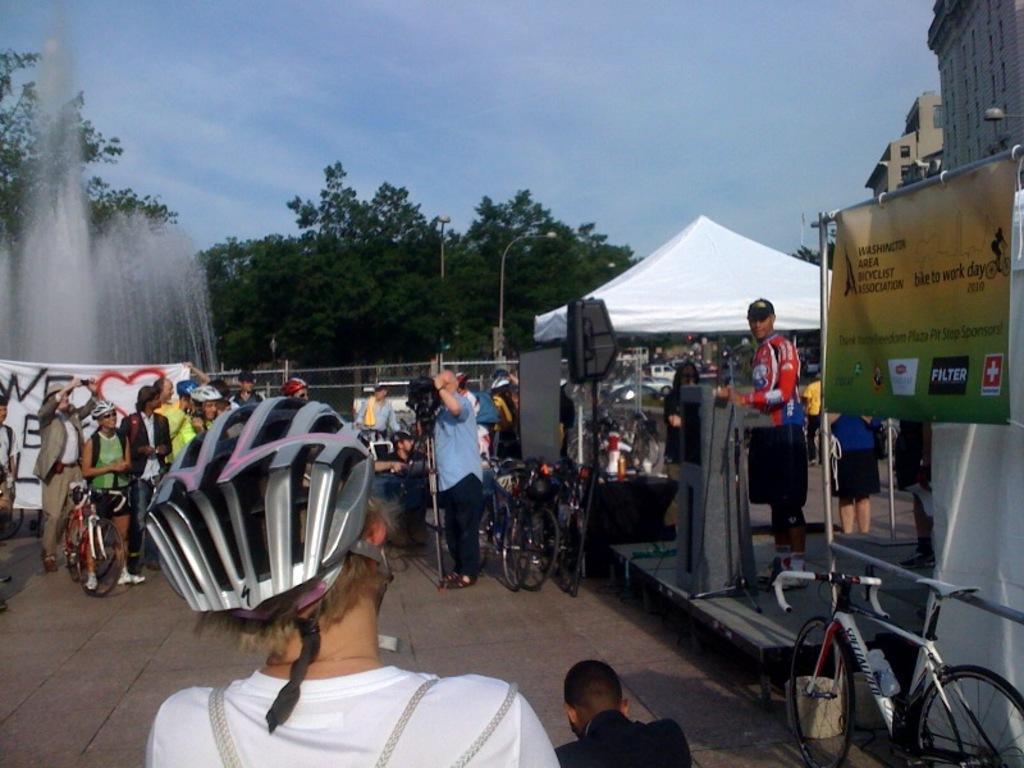In one or two sentences, can you explain what this image depicts? In this image I can see few persons holding bicycles on the ground, a person wearing white colored t shirt is wearing a grey colored helmet. I can see few bicycles, a white colored rent, a fountain, few trees which are cream in color, a banner and few buildings. In the background I can see the sky. 